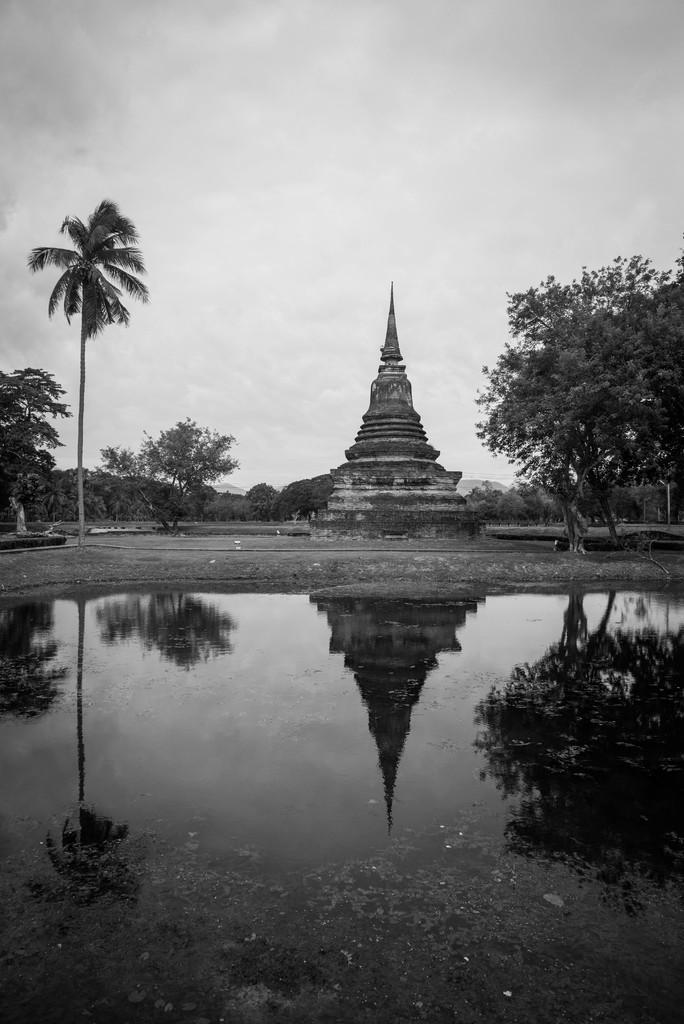Please provide a concise description of this image. This is a black and white image which is clicked outside. In the foreground there is a water body and we can see the reflection of sculpture, trees and the sky on the water body. In the background there is a sky and we can see the sculpture and some trees and some other objects. 